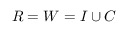Convert formula to latex. <formula><loc_0><loc_0><loc_500><loc_500>R = W = I \cup C</formula> 